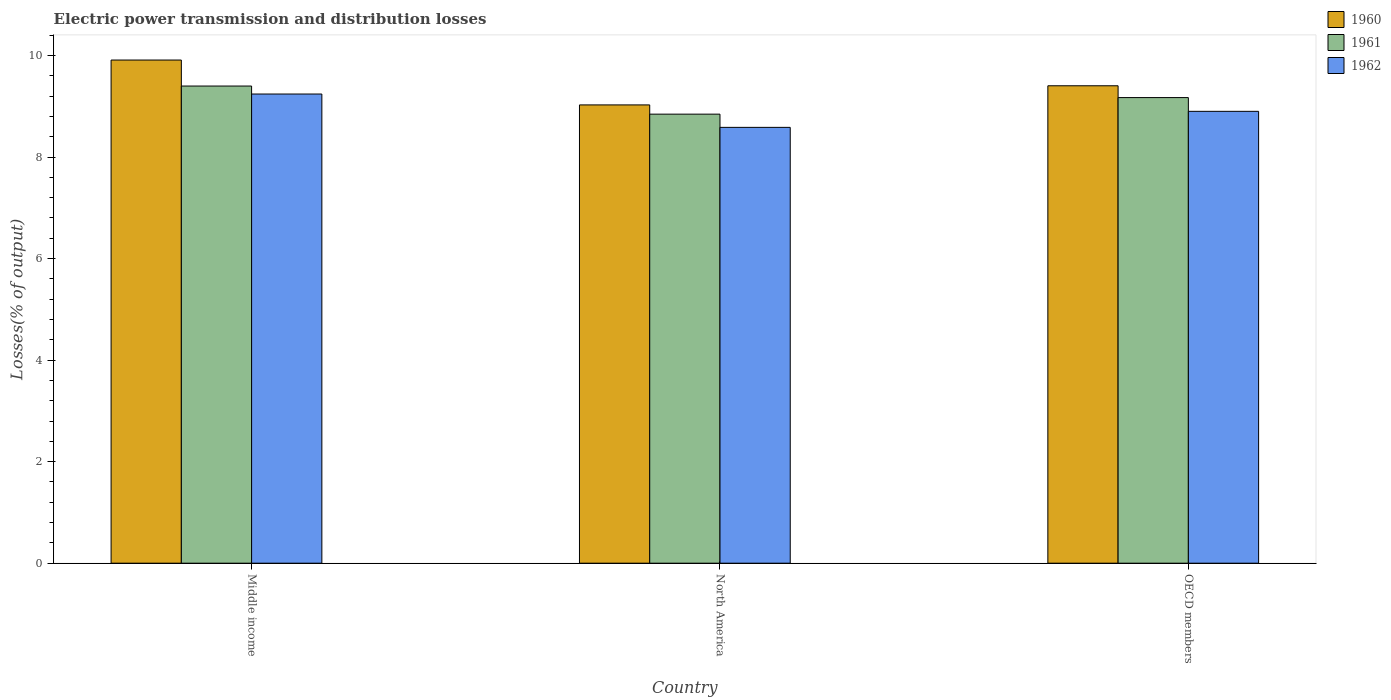How many different coloured bars are there?
Your answer should be very brief. 3. How many groups of bars are there?
Offer a very short reply. 3. Are the number of bars per tick equal to the number of legend labels?
Keep it short and to the point. Yes. How many bars are there on the 2nd tick from the left?
Make the answer very short. 3. How many bars are there on the 2nd tick from the right?
Offer a terse response. 3. What is the label of the 2nd group of bars from the left?
Ensure brevity in your answer.  North America. In how many cases, is the number of bars for a given country not equal to the number of legend labels?
Your answer should be very brief. 0. What is the electric power transmission and distribution losses in 1960 in OECD members?
Ensure brevity in your answer.  9.4. Across all countries, what is the maximum electric power transmission and distribution losses in 1960?
Offer a terse response. 9.91. Across all countries, what is the minimum electric power transmission and distribution losses in 1961?
Offer a terse response. 8.85. In which country was the electric power transmission and distribution losses in 1962 maximum?
Your response must be concise. Middle income. In which country was the electric power transmission and distribution losses in 1960 minimum?
Your response must be concise. North America. What is the total electric power transmission and distribution losses in 1960 in the graph?
Ensure brevity in your answer.  28.34. What is the difference between the electric power transmission and distribution losses in 1962 in North America and that in OECD members?
Offer a terse response. -0.32. What is the difference between the electric power transmission and distribution losses in 1960 in Middle income and the electric power transmission and distribution losses in 1961 in OECD members?
Keep it short and to the point. 0.74. What is the average electric power transmission and distribution losses in 1962 per country?
Your response must be concise. 8.91. What is the difference between the electric power transmission and distribution losses of/in 1961 and electric power transmission and distribution losses of/in 1960 in OECD members?
Your response must be concise. -0.23. In how many countries, is the electric power transmission and distribution losses in 1961 greater than 8.8 %?
Make the answer very short. 3. What is the ratio of the electric power transmission and distribution losses in 1961 in North America to that in OECD members?
Your response must be concise. 0.96. Is the electric power transmission and distribution losses in 1960 in North America less than that in OECD members?
Your answer should be very brief. Yes. Is the difference between the electric power transmission and distribution losses in 1961 in Middle income and OECD members greater than the difference between the electric power transmission and distribution losses in 1960 in Middle income and OECD members?
Keep it short and to the point. No. What is the difference between the highest and the second highest electric power transmission and distribution losses in 1960?
Your answer should be compact. 0.51. What is the difference between the highest and the lowest electric power transmission and distribution losses in 1960?
Keep it short and to the point. 0.88. What does the 2nd bar from the left in Middle income represents?
Your answer should be compact. 1961. What does the 2nd bar from the right in North America represents?
Give a very brief answer. 1961. Is it the case that in every country, the sum of the electric power transmission and distribution losses in 1960 and electric power transmission and distribution losses in 1961 is greater than the electric power transmission and distribution losses in 1962?
Ensure brevity in your answer.  Yes. How many bars are there?
Ensure brevity in your answer.  9. Does the graph contain any zero values?
Make the answer very short. No. Where does the legend appear in the graph?
Ensure brevity in your answer.  Top right. How many legend labels are there?
Your answer should be compact. 3. What is the title of the graph?
Offer a terse response. Electric power transmission and distribution losses. What is the label or title of the Y-axis?
Ensure brevity in your answer.  Losses(% of output). What is the Losses(% of output) in 1960 in Middle income?
Ensure brevity in your answer.  9.91. What is the Losses(% of output) of 1961 in Middle income?
Your response must be concise. 9.4. What is the Losses(% of output) of 1962 in Middle income?
Offer a very short reply. 9.24. What is the Losses(% of output) in 1960 in North America?
Your answer should be compact. 9.03. What is the Losses(% of output) of 1961 in North America?
Provide a succinct answer. 8.85. What is the Losses(% of output) in 1962 in North America?
Give a very brief answer. 8.59. What is the Losses(% of output) of 1960 in OECD members?
Keep it short and to the point. 9.4. What is the Losses(% of output) of 1961 in OECD members?
Ensure brevity in your answer.  9.17. What is the Losses(% of output) of 1962 in OECD members?
Offer a terse response. 8.9. Across all countries, what is the maximum Losses(% of output) in 1960?
Offer a terse response. 9.91. Across all countries, what is the maximum Losses(% of output) of 1961?
Give a very brief answer. 9.4. Across all countries, what is the maximum Losses(% of output) in 1962?
Your answer should be very brief. 9.24. Across all countries, what is the minimum Losses(% of output) in 1960?
Ensure brevity in your answer.  9.03. Across all countries, what is the minimum Losses(% of output) in 1961?
Offer a terse response. 8.85. Across all countries, what is the minimum Losses(% of output) in 1962?
Give a very brief answer. 8.59. What is the total Losses(% of output) in 1960 in the graph?
Your answer should be compact. 28.34. What is the total Losses(% of output) in 1961 in the graph?
Provide a short and direct response. 27.42. What is the total Losses(% of output) of 1962 in the graph?
Offer a terse response. 26.73. What is the difference between the Losses(% of output) in 1960 in Middle income and that in North America?
Provide a succinct answer. 0.88. What is the difference between the Losses(% of output) in 1961 in Middle income and that in North America?
Offer a very short reply. 0.55. What is the difference between the Losses(% of output) of 1962 in Middle income and that in North America?
Your answer should be compact. 0.66. What is the difference between the Losses(% of output) of 1960 in Middle income and that in OECD members?
Offer a very short reply. 0.51. What is the difference between the Losses(% of output) in 1961 in Middle income and that in OECD members?
Your response must be concise. 0.23. What is the difference between the Losses(% of output) of 1962 in Middle income and that in OECD members?
Provide a succinct answer. 0.34. What is the difference between the Losses(% of output) in 1960 in North America and that in OECD members?
Offer a very short reply. -0.38. What is the difference between the Losses(% of output) of 1961 in North America and that in OECD members?
Make the answer very short. -0.33. What is the difference between the Losses(% of output) in 1962 in North America and that in OECD members?
Keep it short and to the point. -0.32. What is the difference between the Losses(% of output) of 1960 in Middle income and the Losses(% of output) of 1961 in North America?
Offer a very short reply. 1.07. What is the difference between the Losses(% of output) in 1960 in Middle income and the Losses(% of output) in 1962 in North America?
Give a very brief answer. 1.33. What is the difference between the Losses(% of output) of 1961 in Middle income and the Losses(% of output) of 1962 in North America?
Your answer should be compact. 0.81. What is the difference between the Losses(% of output) in 1960 in Middle income and the Losses(% of output) in 1961 in OECD members?
Keep it short and to the point. 0.74. What is the difference between the Losses(% of output) in 1960 in Middle income and the Losses(% of output) in 1962 in OECD members?
Provide a short and direct response. 1.01. What is the difference between the Losses(% of output) of 1961 in Middle income and the Losses(% of output) of 1962 in OECD members?
Offer a very short reply. 0.5. What is the difference between the Losses(% of output) of 1960 in North America and the Losses(% of output) of 1961 in OECD members?
Keep it short and to the point. -0.14. What is the difference between the Losses(% of output) in 1960 in North America and the Losses(% of output) in 1962 in OECD members?
Your answer should be compact. 0.13. What is the difference between the Losses(% of output) in 1961 in North America and the Losses(% of output) in 1962 in OECD members?
Offer a terse response. -0.06. What is the average Losses(% of output) in 1960 per country?
Your answer should be very brief. 9.45. What is the average Losses(% of output) of 1961 per country?
Your answer should be very brief. 9.14. What is the average Losses(% of output) of 1962 per country?
Ensure brevity in your answer.  8.91. What is the difference between the Losses(% of output) of 1960 and Losses(% of output) of 1961 in Middle income?
Provide a short and direct response. 0.51. What is the difference between the Losses(% of output) in 1960 and Losses(% of output) in 1962 in Middle income?
Ensure brevity in your answer.  0.67. What is the difference between the Losses(% of output) in 1961 and Losses(% of output) in 1962 in Middle income?
Make the answer very short. 0.16. What is the difference between the Losses(% of output) of 1960 and Losses(% of output) of 1961 in North America?
Your response must be concise. 0.18. What is the difference between the Losses(% of output) in 1960 and Losses(% of output) in 1962 in North America?
Your answer should be very brief. 0.44. What is the difference between the Losses(% of output) of 1961 and Losses(% of output) of 1962 in North America?
Your answer should be very brief. 0.26. What is the difference between the Losses(% of output) in 1960 and Losses(% of output) in 1961 in OECD members?
Offer a terse response. 0.23. What is the difference between the Losses(% of output) of 1960 and Losses(% of output) of 1962 in OECD members?
Provide a succinct answer. 0.5. What is the difference between the Losses(% of output) of 1961 and Losses(% of output) of 1962 in OECD members?
Your response must be concise. 0.27. What is the ratio of the Losses(% of output) of 1960 in Middle income to that in North America?
Make the answer very short. 1.1. What is the ratio of the Losses(% of output) of 1961 in Middle income to that in North America?
Offer a very short reply. 1.06. What is the ratio of the Losses(% of output) in 1962 in Middle income to that in North America?
Provide a succinct answer. 1.08. What is the ratio of the Losses(% of output) of 1960 in Middle income to that in OECD members?
Give a very brief answer. 1.05. What is the ratio of the Losses(% of output) in 1961 in Middle income to that in OECD members?
Offer a very short reply. 1.02. What is the ratio of the Losses(% of output) of 1962 in Middle income to that in OECD members?
Your answer should be very brief. 1.04. What is the ratio of the Losses(% of output) in 1960 in North America to that in OECD members?
Provide a short and direct response. 0.96. What is the ratio of the Losses(% of output) of 1961 in North America to that in OECD members?
Your answer should be compact. 0.96. What is the ratio of the Losses(% of output) of 1962 in North America to that in OECD members?
Provide a short and direct response. 0.96. What is the difference between the highest and the second highest Losses(% of output) in 1960?
Offer a terse response. 0.51. What is the difference between the highest and the second highest Losses(% of output) of 1961?
Your response must be concise. 0.23. What is the difference between the highest and the second highest Losses(% of output) in 1962?
Keep it short and to the point. 0.34. What is the difference between the highest and the lowest Losses(% of output) in 1960?
Your answer should be compact. 0.88. What is the difference between the highest and the lowest Losses(% of output) in 1961?
Provide a short and direct response. 0.55. What is the difference between the highest and the lowest Losses(% of output) of 1962?
Offer a terse response. 0.66. 